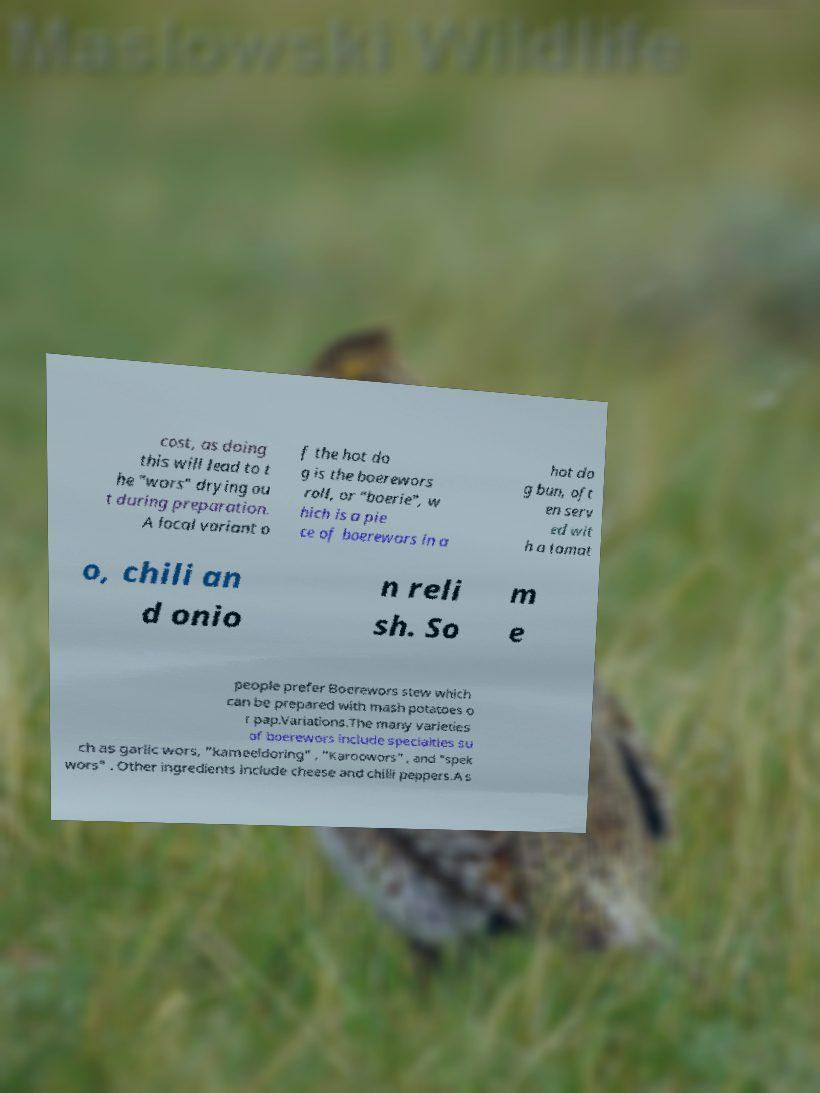Could you extract and type out the text from this image? cost, as doing this will lead to t he "wors" drying ou t during preparation. A local variant o f the hot do g is the boerewors roll, or "boerie", w hich is a pie ce of boerewors in a hot do g bun, oft en serv ed wit h a tomat o, chili an d onio n reli sh. So m e people prefer Boerewors stew which can be prepared with mash potatoes o r pap.Variations.The many varieties of boerewors include specialties su ch as garlic wors, "kameeldoring" , "Karoowors" , and "spek wors" . Other ingredients include cheese and chilli peppers.A s 